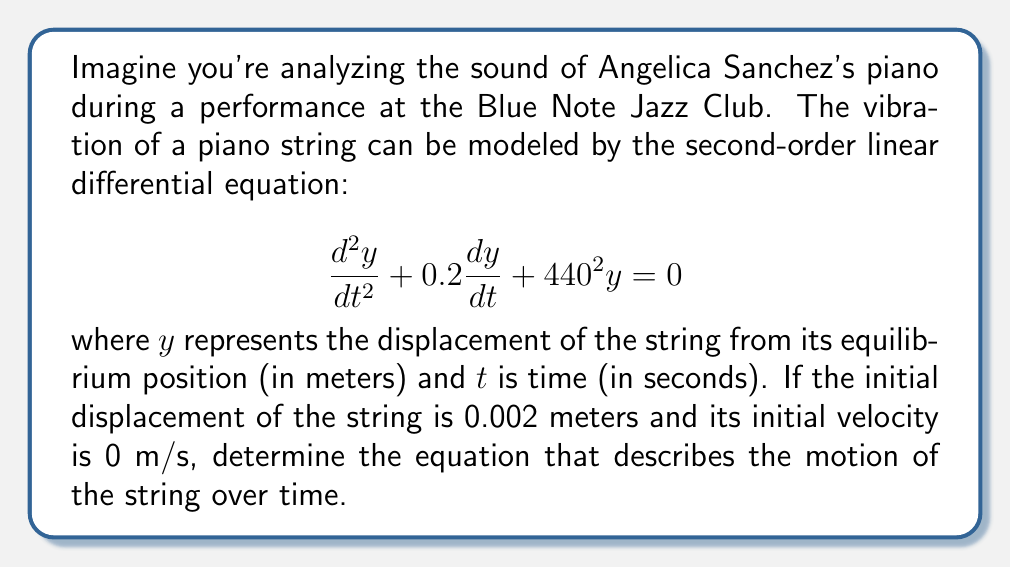Give your solution to this math problem. To solve this problem, we'll follow these steps:

1) The general form of a second-order linear differential equation is:

   $$\frac{d^2y}{dt^2} + 2\zeta\omega_n\frac{dy}{dt} + \omega_n^2y = 0$$

   where $\zeta$ is the damping ratio and $\omega_n$ is the natural frequency.

2) Comparing our equation to the general form, we can identify:
   
   $2\zeta\omega_n = 0.2$ and $\omega_n^2 = 440^2$

3) From this, we can calculate:
   
   $\omega_n = 440$ rad/s
   $\zeta = \frac{0.2}{2(440)} = 0.000227$

4) Since $\zeta < 1$, this is an underdamped system. The solution has the form:

   $$y(t) = Ae^{-\zeta\omega_n t}\cos(\omega_d t - \phi)$$

   where $\omega_d = \omega_n\sqrt{1-\zeta^2}$

5) Calculate $\omega_d$:
   
   $$\omega_d = 440\sqrt{1-(0.000227)^2} \approx 440$$ rad/s

6) Use the initial conditions to find $A$ and $\phi$:
   
   At $t=0$, $y(0) = 0.002 = A\cos(\phi)$
   
   $\frac{dy}{dt}(0) = 0 = -A\zeta\omega_n\cos(\phi) - A\omega_d\sin(\phi)$

7) From the second equation:

   $$\tan(\phi) = -\frac{\zeta\omega_n}{\omega_d} \approx -0.000227$$
   
   $$\phi \approx -0.000227$$ rad

8) From the first equation:
   
   $$A = \frac{0.002}{\cos(-0.000227)} \approx 0.002$$ m

Therefore, the equation of motion is:

$$y(t) = 0.002e^{-0.1t}\cos(440t + 0.000227)$$
Answer: $$y(t) = 0.002e^{-0.1t}\cos(440t + 0.000227)$$
where $y$ is in meters and $t$ is in seconds. 